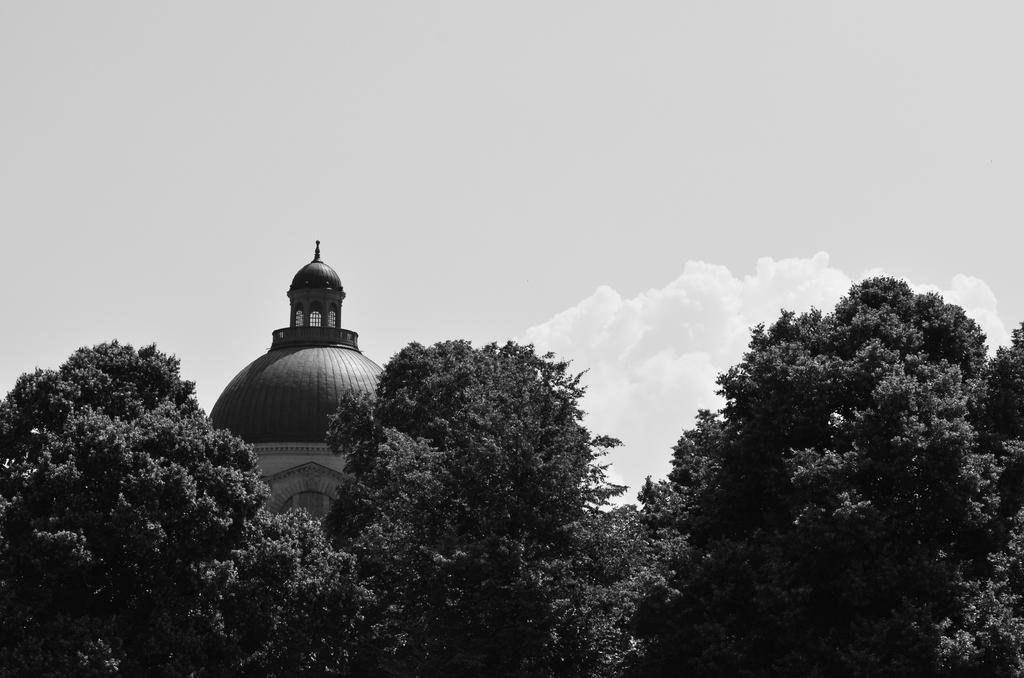What is the color scheme of the image? The image is in black and white. What type of natural elements can be seen in the image? There are many trees in the image. What type of structure is visible in the image? There is a building in the image, with a top view. What can be seen in the sky in the image? There are clouds in the sky. What type of weather is depicted in the image? The provided facts do not mention any specific weather conditions, so we cannot determine the weather from the image. 